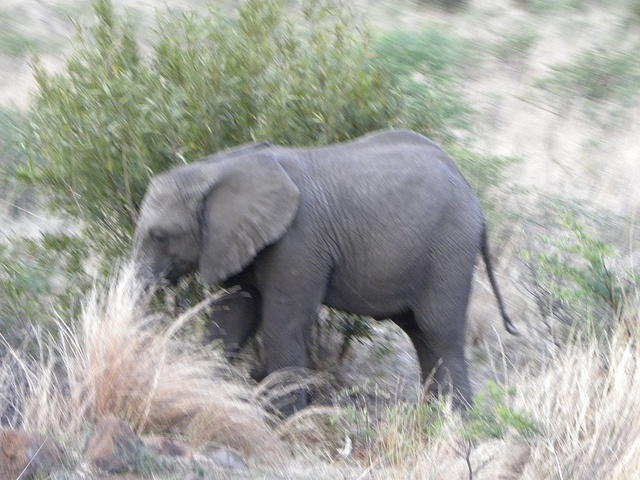Describe the objects in this image and their specific colors. I can see a elephant in lightgray, gray, darkgray, and black tones in this image. 